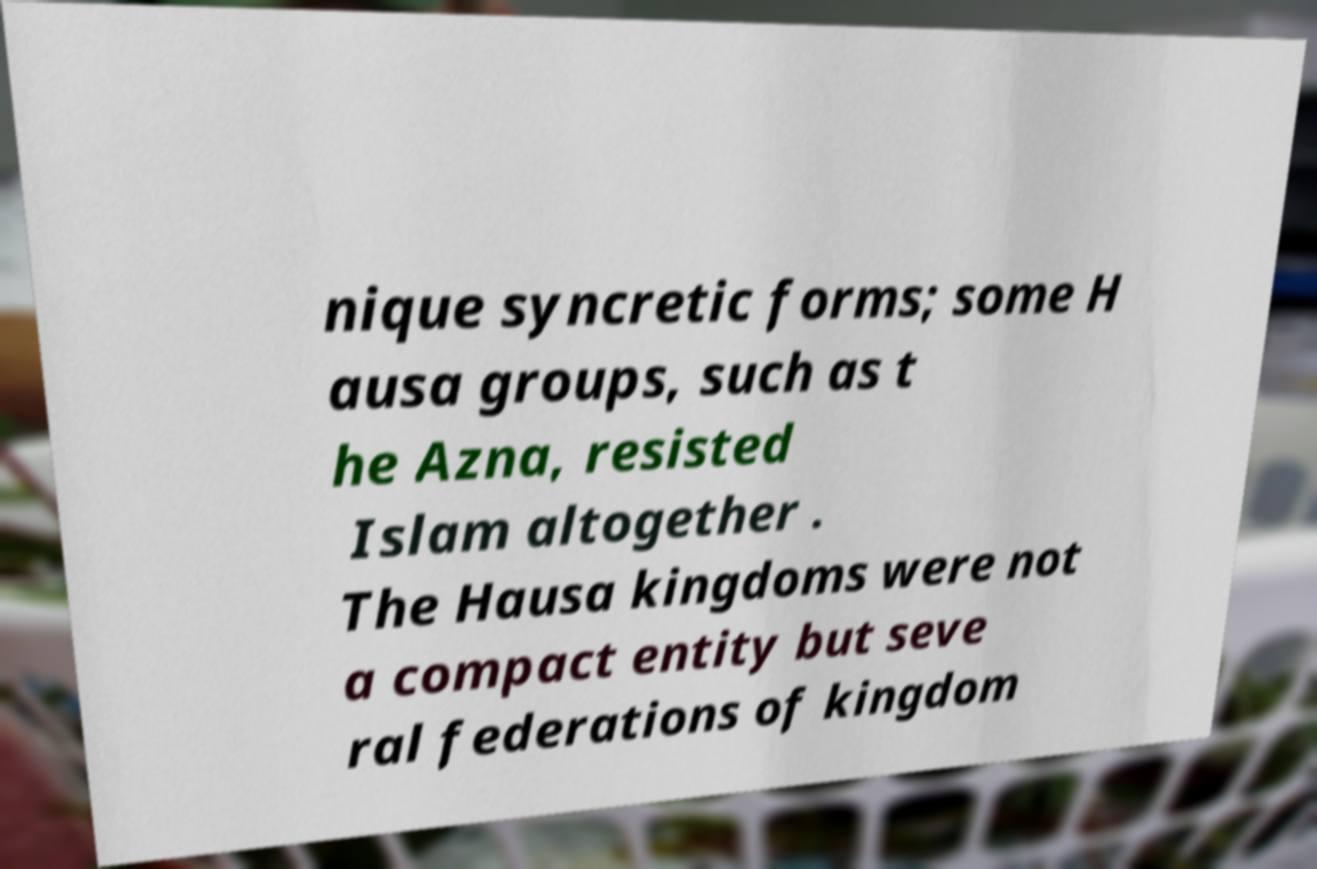Please identify and transcribe the text found in this image. nique syncretic forms; some H ausa groups, such as t he Azna, resisted Islam altogether . The Hausa kingdoms were not a compact entity but seve ral federations of kingdom 